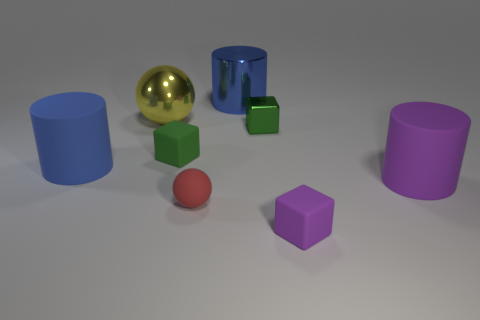How many other rubber spheres are the same color as the small matte ball?
Your response must be concise. 0. There is a blue metallic thing that is the same size as the yellow shiny sphere; what is its shape?
Offer a very short reply. Cylinder. There is a big ball; are there any big yellow balls behind it?
Your answer should be very brief. No. Do the green rubber cube and the blue metal object have the same size?
Ensure brevity in your answer.  No. There is a tiny object to the left of the small ball; what is its shape?
Give a very brief answer. Cube. Are there any shiny cylinders of the same size as the purple matte cylinder?
Keep it short and to the point. Yes. There is another green cube that is the same size as the green rubber cube; what material is it?
Ensure brevity in your answer.  Metal. How big is the rubber block on the left side of the metal cylinder?
Provide a short and direct response. Small. What size is the yellow shiny thing?
Keep it short and to the point. Large. There is a red object; is it the same size as the cylinder that is behind the tiny green rubber block?
Provide a succinct answer. No. 